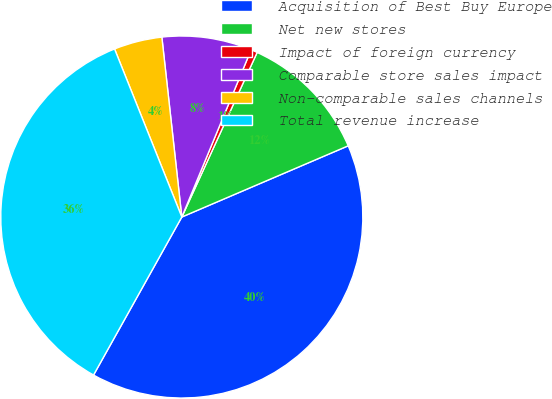<chart> <loc_0><loc_0><loc_500><loc_500><pie_chart><fcel>Acquisition of Best Buy Europe<fcel>Net new stores<fcel>Impact of foreign currency<fcel>Comparable store sales impact<fcel>Non-comparable sales channels<fcel>Total revenue increase<nl><fcel>39.54%<fcel>11.73%<fcel>0.58%<fcel>8.01%<fcel>4.3%<fcel>35.83%<nl></chart> 